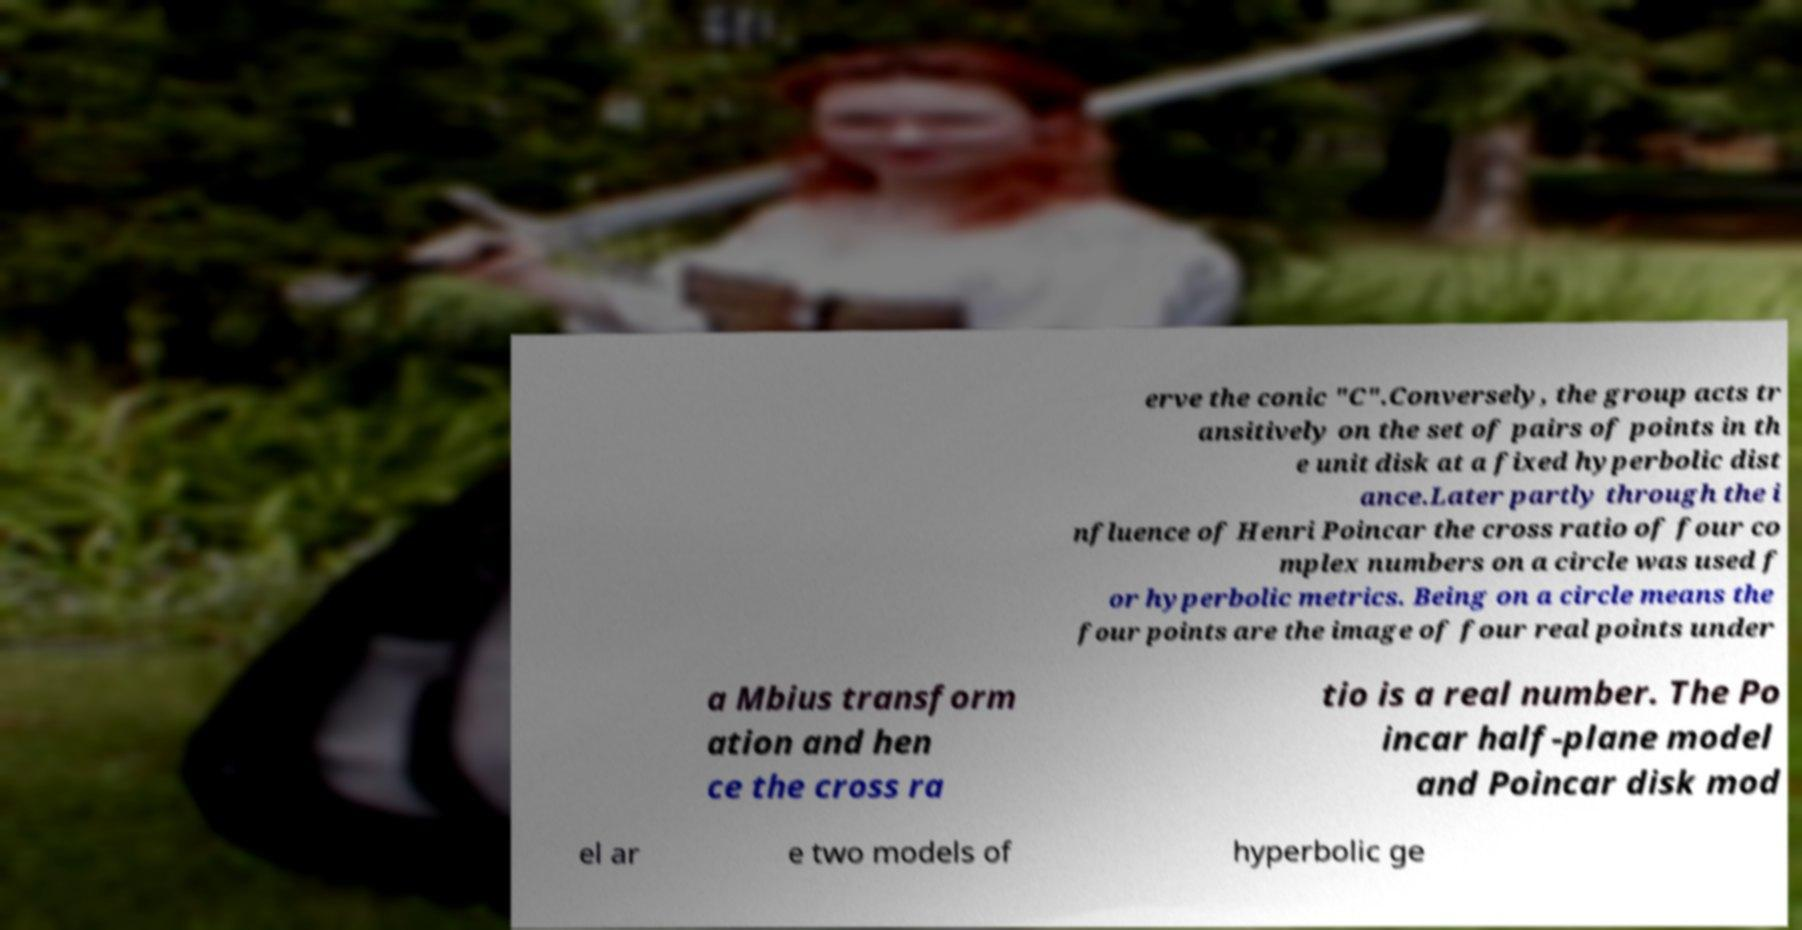What messages or text are displayed in this image? I need them in a readable, typed format. erve the conic "C".Conversely, the group acts tr ansitively on the set of pairs of points in th e unit disk at a fixed hyperbolic dist ance.Later partly through the i nfluence of Henri Poincar the cross ratio of four co mplex numbers on a circle was used f or hyperbolic metrics. Being on a circle means the four points are the image of four real points under a Mbius transform ation and hen ce the cross ra tio is a real number. The Po incar half-plane model and Poincar disk mod el ar e two models of hyperbolic ge 